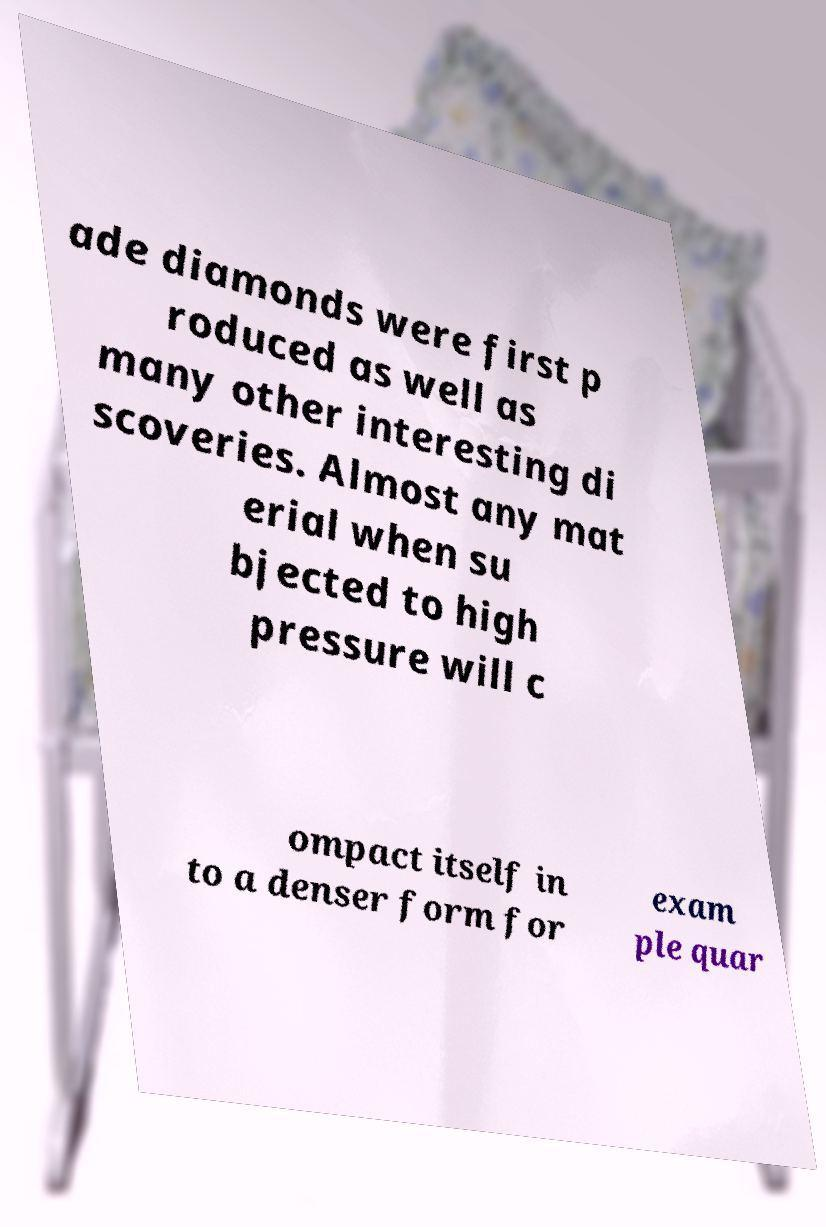Can you accurately transcribe the text from the provided image for me? ade diamonds were first p roduced as well as many other interesting di scoveries. Almost any mat erial when su bjected to high pressure will c ompact itself in to a denser form for exam ple quar 